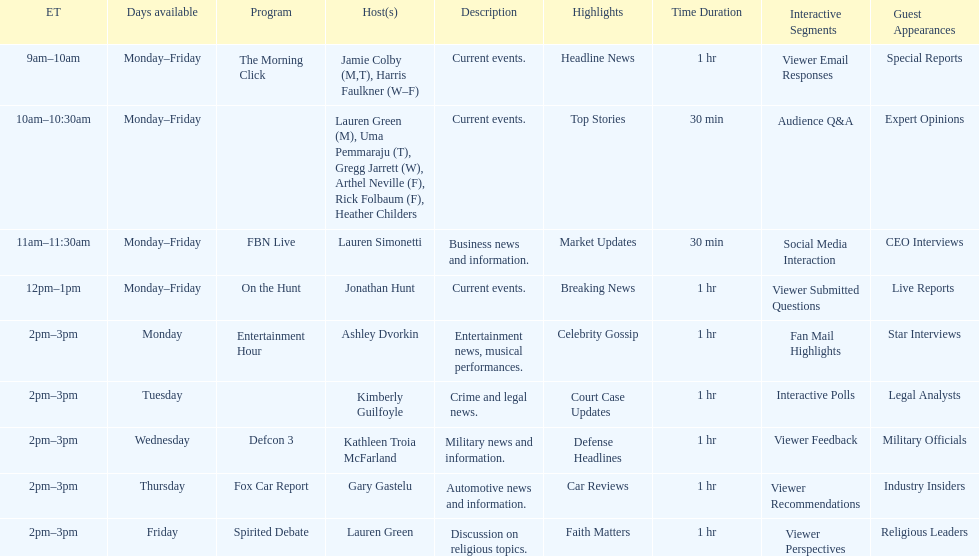How many days during the week does the show fbn live air? 5. 